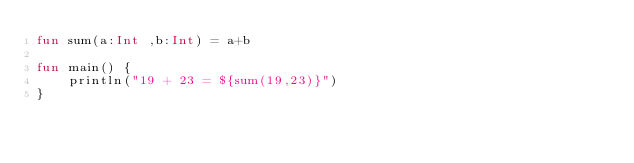Convert code to text. <code><loc_0><loc_0><loc_500><loc_500><_Kotlin_>fun sum(a:Int ,b:Int) = a+b

fun main() {
    println("19 + 23 = ${sum(19,23)}")
}</code> 